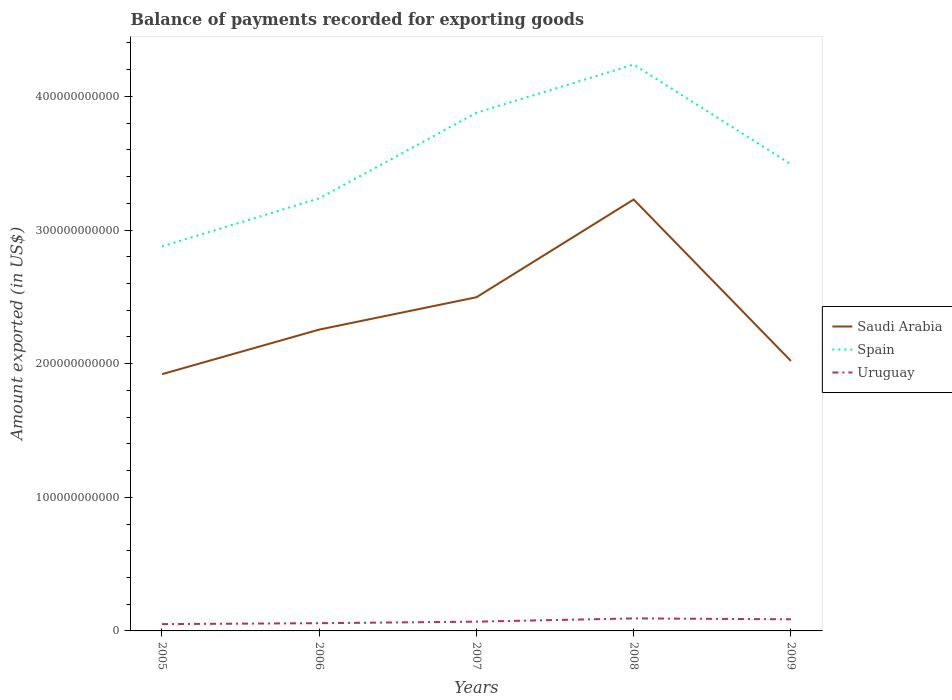Is the number of lines equal to the number of legend labels?
Your response must be concise. Yes. Across all years, what is the maximum amount exported in Spain?
Give a very brief answer. 2.88e+11. What is the total amount exported in Uruguay in the graph?
Provide a succinct answer. -1.15e+09. What is the difference between the highest and the second highest amount exported in Spain?
Keep it short and to the point. 1.36e+11. What is the difference between the highest and the lowest amount exported in Saudi Arabia?
Ensure brevity in your answer.  2. What is the difference between two consecutive major ticks on the Y-axis?
Your response must be concise. 1.00e+11. Are the values on the major ticks of Y-axis written in scientific E-notation?
Ensure brevity in your answer.  No. Does the graph contain any zero values?
Offer a very short reply. No. How are the legend labels stacked?
Make the answer very short. Vertical. What is the title of the graph?
Offer a very short reply. Balance of payments recorded for exporting goods. Does "Turks and Caicos Islands" appear as one of the legend labels in the graph?
Keep it short and to the point. No. What is the label or title of the X-axis?
Ensure brevity in your answer.  Years. What is the label or title of the Y-axis?
Give a very brief answer. Amount exported (in US$). What is the Amount exported (in US$) of Saudi Arabia in 2005?
Your response must be concise. 1.92e+11. What is the Amount exported (in US$) of Spain in 2005?
Offer a very short reply. 2.88e+11. What is the Amount exported (in US$) in Uruguay in 2005?
Provide a short and direct response. 5.09e+09. What is the Amount exported (in US$) of Saudi Arabia in 2006?
Ensure brevity in your answer.  2.26e+11. What is the Amount exported (in US$) of Spain in 2006?
Your response must be concise. 3.24e+11. What is the Amount exported (in US$) in Uruguay in 2006?
Keep it short and to the point. 5.79e+09. What is the Amount exported (in US$) of Saudi Arabia in 2007?
Provide a short and direct response. 2.50e+11. What is the Amount exported (in US$) in Spain in 2007?
Give a very brief answer. 3.88e+11. What is the Amount exported (in US$) in Uruguay in 2007?
Offer a terse response. 6.93e+09. What is the Amount exported (in US$) of Saudi Arabia in 2008?
Offer a terse response. 3.23e+11. What is the Amount exported (in US$) of Spain in 2008?
Give a very brief answer. 4.24e+11. What is the Amount exported (in US$) of Uruguay in 2008?
Keep it short and to the point. 9.37e+09. What is the Amount exported (in US$) in Saudi Arabia in 2009?
Give a very brief answer. 2.02e+11. What is the Amount exported (in US$) in Spain in 2009?
Offer a terse response. 3.49e+11. What is the Amount exported (in US$) in Uruguay in 2009?
Keep it short and to the point. 8.71e+09. Across all years, what is the maximum Amount exported (in US$) in Saudi Arabia?
Offer a very short reply. 3.23e+11. Across all years, what is the maximum Amount exported (in US$) in Spain?
Provide a short and direct response. 4.24e+11. Across all years, what is the maximum Amount exported (in US$) in Uruguay?
Offer a very short reply. 9.37e+09. Across all years, what is the minimum Amount exported (in US$) in Saudi Arabia?
Provide a succinct answer. 1.92e+11. Across all years, what is the minimum Amount exported (in US$) of Spain?
Provide a succinct answer. 2.88e+11. Across all years, what is the minimum Amount exported (in US$) in Uruguay?
Provide a succinct answer. 5.09e+09. What is the total Amount exported (in US$) in Saudi Arabia in the graph?
Give a very brief answer. 1.19e+12. What is the total Amount exported (in US$) in Spain in the graph?
Provide a succinct answer. 1.77e+12. What is the total Amount exported (in US$) of Uruguay in the graph?
Your answer should be compact. 3.59e+1. What is the difference between the Amount exported (in US$) in Saudi Arabia in 2005 and that in 2006?
Offer a very short reply. -3.34e+1. What is the difference between the Amount exported (in US$) of Spain in 2005 and that in 2006?
Your response must be concise. -3.59e+1. What is the difference between the Amount exported (in US$) in Uruguay in 2005 and that in 2006?
Your answer should be compact. -7.02e+08. What is the difference between the Amount exported (in US$) in Saudi Arabia in 2005 and that in 2007?
Offer a very short reply. -5.76e+1. What is the difference between the Amount exported (in US$) in Spain in 2005 and that in 2007?
Keep it short and to the point. -1.00e+11. What is the difference between the Amount exported (in US$) in Uruguay in 2005 and that in 2007?
Your answer should be compact. -1.85e+09. What is the difference between the Amount exported (in US$) in Saudi Arabia in 2005 and that in 2008?
Ensure brevity in your answer.  -1.31e+11. What is the difference between the Amount exported (in US$) of Spain in 2005 and that in 2008?
Your response must be concise. -1.36e+11. What is the difference between the Amount exported (in US$) of Uruguay in 2005 and that in 2008?
Keep it short and to the point. -4.29e+09. What is the difference between the Amount exported (in US$) of Saudi Arabia in 2005 and that in 2009?
Give a very brief answer. -9.94e+09. What is the difference between the Amount exported (in US$) of Spain in 2005 and that in 2009?
Offer a very short reply. -6.15e+1. What is the difference between the Amount exported (in US$) in Uruguay in 2005 and that in 2009?
Ensure brevity in your answer.  -3.63e+09. What is the difference between the Amount exported (in US$) in Saudi Arabia in 2006 and that in 2007?
Offer a terse response. -2.42e+1. What is the difference between the Amount exported (in US$) in Spain in 2006 and that in 2007?
Your answer should be compact. -6.41e+1. What is the difference between the Amount exported (in US$) in Uruguay in 2006 and that in 2007?
Your response must be concise. -1.15e+09. What is the difference between the Amount exported (in US$) of Saudi Arabia in 2006 and that in 2008?
Give a very brief answer. -9.73e+1. What is the difference between the Amount exported (in US$) of Spain in 2006 and that in 2008?
Your answer should be very brief. -1.00e+11. What is the difference between the Amount exported (in US$) in Uruguay in 2006 and that in 2008?
Your answer should be very brief. -3.58e+09. What is the difference between the Amount exported (in US$) in Saudi Arabia in 2006 and that in 2009?
Your answer should be very brief. 2.34e+1. What is the difference between the Amount exported (in US$) of Spain in 2006 and that in 2009?
Ensure brevity in your answer.  -2.55e+1. What is the difference between the Amount exported (in US$) of Uruguay in 2006 and that in 2009?
Your answer should be compact. -2.92e+09. What is the difference between the Amount exported (in US$) of Saudi Arabia in 2007 and that in 2008?
Keep it short and to the point. -7.31e+1. What is the difference between the Amount exported (in US$) in Spain in 2007 and that in 2008?
Provide a short and direct response. -3.61e+1. What is the difference between the Amount exported (in US$) in Uruguay in 2007 and that in 2008?
Offer a terse response. -2.44e+09. What is the difference between the Amount exported (in US$) in Saudi Arabia in 2007 and that in 2009?
Ensure brevity in your answer.  4.77e+1. What is the difference between the Amount exported (in US$) of Spain in 2007 and that in 2009?
Your answer should be compact. 3.85e+1. What is the difference between the Amount exported (in US$) in Uruguay in 2007 and that in 2009?
Your answer should be very brief. -1.78e+09. What is the difference between the Amount exported (in US$) in Saudi Arabia in 2008 and that in 2009?
Offer a terse response. 1.21e+11. What is the difference between the Amount exported (in US$) in Spain in 2008 and that in 2009?
Offer a terse response. 7.46e+1. What is the difference between the Amount exported (in US$) in Uruguay in 2008 and that in 2009?
Provide a succinct answer. 6.61e+08. What is the difference between the Amount exported (in US$) of Saudi Arabia in 2005 and the Amount exported (in US$) of Spain in 2006?
Offer a terse response. -1.32e+11. What is the difference between the Amount exported (in US$) in Saudi Arabia in 2005 and the Amount exported (in US$) in Uruguay in 2006?
Your answer should be very brief. 1.86e+11. What is the difference between the Amount exported (in US$) in Spain in 2005 and the Amount exported (in US$) in Uruguay in 2006?
Offer a terse response. 2.82e+11. What is the difference between the Amount exported (in US$) in Saudi Arabia in 2005 and the Amount exported (in US$) in Spain in 2007?
Provide a short and direct response. -1.96e+11. What is the difference between the Amount exported (in US$) in Saudi Arabia in 2005 and the Amount exported (in US$) in Uruguay in 2007?
Your response must be concise. 1.85e+11. What is the difference between the Amount exported (in US$) in Spain in 2005 and the Amount exported (in US$) in Uruguay in 2007?
Provide a short and direct response. 2.81e+11. What is the difference between the Amount exported (in US$) of Saudi Arabia in 2005 and the Amount exported (in US$) of Spain in 2008?
Ensure brevity in your answer.  -2.32e+11. What is the difference between the Amount exported (in US$) of Saudi Arabia in 2005 and the Amount exported (in US$) of Uruguay in 2008?
Provide a succinct answer. 1.83e+11. What is the difference between the Amount exported (in US$) of Spain in 2005 and the Amount exported (in US$) of Uruguay in 2008?
Your response must be concise. 2.78e+11. What is the difference between the Amount exported (in US$) of Saudi Arabia in 2005 and the Amount exported (in US$) of Spain in 2009?
Your answer should be very brief. -1.57e+11. What is the difference between the Amount exported (in US$) in Saudi Arabia in 2005 and the Amount exported (in US$) in Uruguay in 2009?
Offer a very short reply. 1.83e+11. What is the difference between the Amount exported (in US$) of Spain in 2005 and the Amount exported (in US$) of Uruguay in 2009?
Your answer should be compact. 2.79e+11. What is the difference between the Amount exported (in US$) in Saudi Arabia in 2006 and the Amount exported (in US$) in Spain in 2007?
Your answer should be compact. -1.62e+11. What is the difference between the Amount exported (in US$) of Saudi Arabia in 2006 and the Amount exported (in US$) of Uruguay in 2007?
Keep it short and to the point. 2.19e+11. What is the difference between the Amount exported (in US$) in Spain in 2006 and the Amount exported (in US$) in Uruguay in 2007?
Offer a very short reply. 3.17e+11. What is the difference between the Amount exported (in US$) of Saudi Arabia in 2006 and the Amount exported (in US$) of Spain in 2008?
Give a very brief answer. -1.98e+11. What is the difference between the Amount exported (in US$) in Saudi Arabia in 2006 and the Amount exported (in US$) in Uruguay in 2008?
Provide a short and direct response. 2.16e+11. What is the difference between the Amount exported (in US$) in Spain in 2006 and the Amount exported (in US$) in Uruguay in 2008?
Ensure brevity in your answer.  3.14e+11. What is the difference between the Amount exported (in US$) in Saudi Arabia in 2006 and the Amount exported (in US$) in Spain in 2009?
Offer a terse response. -1.24e+11. What is the difference between the Amount exported (in US$) in Saudi Arabia in 2006 and the Amount exported (in US$) in Uruguay in 2009?
Ensure brevity in your answer.  2.17e+11. What is the difference between the Amount exported (in US$) in Spain in 2006 and the Amount exported (in US$) in Uruguay in 2009?
Your response must be concise. 3.15e+11. What is the difference between the Amount exported (in US$) in Saudi Arabia in 2007 and the Amount exported (in US$) in Spain in 2008?
Ensure brevity in your answer.  -1.74e+11. What is the difference between the Amount exported (in US$) in Saudi Arabia in 2007 and the Amount exported (in US$) in Uruguay in 2008?
Your response must be concise. 2.40e+11. What is the difference between the Amount exported (in US$) in Spain in 2007 and the Amount exported (in US$) in Uruguay in 2008?
Provide a succinct answer. 3.78e+11. What is the difference between the Amount exported (in US$) of Saudi Arabia in 2007 and the Amount exported (in US$) of Spain in 2009?
Your response must be concise. -9.95e+1. What is the difference between the Amount exported (in US$) in Saudi Arabia in 2007 and the Amount exported (in US$) in Uruguay in 2009?
Your response must be concise. 2.41e+11. What is the difference between the Amount exported (in US$) in Spain in 2007 and the Amount exported (in US$) in Uruguay in 2009?
Keep it short and to the point. 3.79e+11. What is the difference between the Amount exported (in US$) in Saudi Arabia in 2008 and the Amount exported (in US$) in Spain in 2009?
Your answer should be compact. -2.64e+1. What is the difference between the Amount exported (in US$) of Saudi Arabia in 2008 and the Amount exported (in US$) of Uruguay in 2009?
Your response must be concise. 3.14e+11. What is the difference between the Amount exported (in US$) of Spain in 2008 and the Amount exported (in US$) of Uruguay in 2009?
Your response must be concise. 4.15e+11. What is the average Amount exported (in US$) of Saudi Arabia per year?
Offer a terse response. 2.38e+11. What is the average Amount exported (in US$) in Spain per year?
Your answer should be very brief. 3.54e+11. What is the average Amount exported (in US$) in Uruguay per year?
Offer a terse response. 7.18e+09. In the year 2005, what is the difference between the Amount exported (in US$) of Saudi Arabia and Amount exported (in US$) of Spain?
Your response must be concise. -9.56e+1. In the year 2005, what is the difference between the Amount exported (in US$) in Saudi Arabia and Amount exported (in US$) in Uruguay?
Keep it short and to the point. 1.87e+11. In the year 2005, what is the difference between the Amount exported (in US$) in Spain and Amount exported (in US$) in Uruguay?
Keep it short and to the point. 2.83e+11. In the year 2006, what is the difference between the Amount exported (in US$) in Saudi Arabia and Amount exported (in US$) in Spain?
Your answer should be very brief. -9.82e+1. In the year 2006, what is the difference between the Amount exported (in US$) in Saudi Arabia and Amount exported (in US$) in Uruguay?
Give a very brief answer. 2.20e+11. In the year 2006, what is the difference between the Amount exported (in US$) of Spain and Amount exported (in US$) of Uruguay?
Provide a short and direct response. 3.18e+11. In the year 2007, what is the difference between the Amount exported (in US$) in Saudi Arabia and Amount exported (in US$) in Spain?
Give a very brief answer. -1.38e+11. In the year 2007, what is the difference between the Amount exported (in US$) of Saudi Arabia and Amount exported (in US$) of Uruguay?
Keep it short and to the point. 2.43e+11. In the year 2007, what is the difference between the Amount exported (in US$) of Spain and Amount exported (in US$) of Uruguay?
Your answer should be very brief. 3.81e+11. In the year 2008, what is the difference between the Amount exported (in US$) of Saudi Arabia and Amount exported (in US$) of Spain?
Provide a succinct answer. -1.01e+11. In the year 2008, what is the difference between the Amount exported (in US$) of Saudi Arabia and Amount exported (in US$) of Uruguay?
Provide a short and direct response. 3.13e+11. In the year 2008, what is the difference between the Amount exported (in US$) in Spain and Amount exported (in US$) in Uruguay?
Provide a succinct answer. 4.14e+11. In the year 2009, what is the difference between the Amount exported (in US$) in Saudi Arabia and Amount exported (in US$) in Spain?
Make the answer very short. -1.47e+11. In the year 2009, what is the difference between the Amount exported (in US$) in Saudi Arabia and Amount exported (in US$) in Uruguay?
Offer a very short reply. 1.93e+11. In the year 2009, what is the difference between the Amount exported (in US$) in Spain and Amount exported (in US$) in Uruguay?
Offer a very short reply. 3.41e+11. What is the ratio of the Amount exported (in US$) in Saudi Arabia in 2005 to that in 2006?
Your answer should be compact. 0.85. What is the ratio of the Amount exported (in US$) in Spain in 2005 to that in 2006?
Ensure brevity in your answer.  0.89. What is the ratio of the Amount exported (in US$) in Uruguay in 2005 to that in 2006?
Your answer should be compact. 0.88. What is the ratio of the Amount exported (in US$) in Saudi Arabia in 2005 to that in 2007?
Give a very brief answer. 0.77. What is the ratio of the Amount exported (in US$) of Spain in 2005 to that in 2007?
Offer a very short reply. 0.74. What is the ratio of the Amount exported (in US$) in Uruguay in 2005 to that in 2007?
Offer a very short reply. 0.73. What is the ratio of the Amount exported (in US$) in Saudi Arabia in 2005 to that in 2008?
Your answer should be very brief. 0.6. What is the ratio of the Amount exported (in US$) of Spain in 2005 to that in 2008?
Your answer should be very brief. 0.68. What is the ratio of the Amount exported (in US$) in Uruguay in 2005 to that in 2008?
Your response must be concise. 0.54. What is the ratio of the Amount exported (in US$) of Saudi Arabia in 2005 to that in 2009?
Provide a short and direct response. 0.95. What is the ratio of the Amount exported (in US$) of Spain in 2005 to that in 2009?
Provide a succinct answer. 0.82. What is the ratio of the Amount exported (in US$) of Uruguay in 2005 to that in 2009?
Keep it short and to the point. 0.58. What is the ratio of the Amount exported (in US$) of Saudi Arabia in 2006 to that in 2007?
Your answer should be very brief. 0.9. What is the ratio of the Amount exported (in US$) in Spain in 2006 to that in 2007?
Provide a short and direct response. 0.83. What is the ratio of the Amount exported (in US$) of Uruguay in 2006 to that in 2007?
Your answer should be compact. 0.83. What is the ratio of the Amount exported (in US$) of Saudi Arabia in 2006 to that in 2008?
Keep it short and to the point. 0.7. What is the ratio of the Amount exported (in US$) of Spain in 2006 to that in 2008?
Ensure brevity in your answer.  0.76. What is the ratio of the Amount exported (in US$) in Uruguay in 2006 to that in 2008?
Ensure brevity in your answer.  0.62. What is the ratio of the Amount exported (in US$) in Saudi Arabia in 2006 to that in 2009?
Offer a terse response. 1.12. What is the ratio of the Amount exported (in US$) in Spain in 2006 to that in 2009?
Make the answer very short. 0.93. What is the ratio of the Amount exported (in US$) of Uruguay in 2006 to that in 2009?
Offer a very short reply. 0.66. What is the ratio of the Amount exported (in US$) in Saudi Arabia in 2007 to that in 2008?
Make the answer very short. 0.77. What is the ratio of the Amount exported (in US$) in Spain in 2007 to that in 2008?
Give a very brief answer. 0.91. What is the ratio of the Amount exported (in US$) of Uruguay in 2007 to that in 2008?
Keep it short and to the point. 0.74. What is the ratio of the Amount exported (in US$) in Saudi Arabia in 2007 to that in 2009?
Keep it short and to the point. 1.24. What is the ratio of the Amount exported (in US$) of Spain in 2007 to that in 2009?
Offer a terse response. 1.11. What is the ratio of the Amount exported (in US$) in Uruguay in 2007 to that in 2009?
Make the answer very short. 0.8. What is the ratio of the Amount exported (in US$) in Saudi Arabia in 2008 to that in 2009?
Give a very brief answer. 1.6. What is the ratio of the Amount exported (in US$) in Spain in 2008 to that in 2009?
Make the answer very short. 1.21. What is the ratio of the Amount exported (in US$) in Uruguay in 2008 to that in 2009?
Make the answer very short. 1.08. What is the difference between the highest and the second highest Amount exported (in US$) in Saudi Arabia?
Your answer should be very brief. 7.31e+1. What is the difference between the highest and the second highest Amount exported (in US$) in Spain?
Provide a succinct answer. 3.61e+1. What is the difference between the highest and the second highest Amount exported (in US$) of Uruguay?
Ensure brevity in your answer.  6.61e+08. What is the difference between the highest and the lowest Amount exported (in US$) of Saudi Arabia?
Ensure brevity in your answer.  1.31e+11. What is the difference between the highest and the lowest Amount exported (in US$) of Spain?
Ensure brevity in your answer.  1.36e+11. What is the difference between the highest and the lowest Amount exported (in US$) of Uruguay?
Keep it short and to the point. 4.29e+09. 